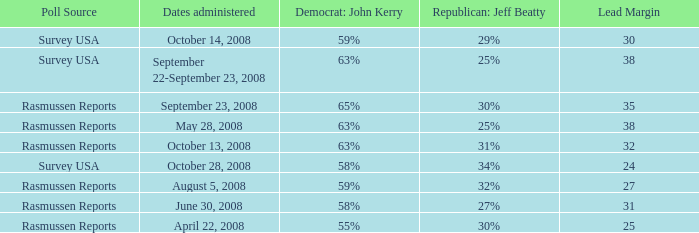What are the dates where democrat john kerry is 63% and poll source is rasmussen reports? October 13, 2008, May 28, 2008. 